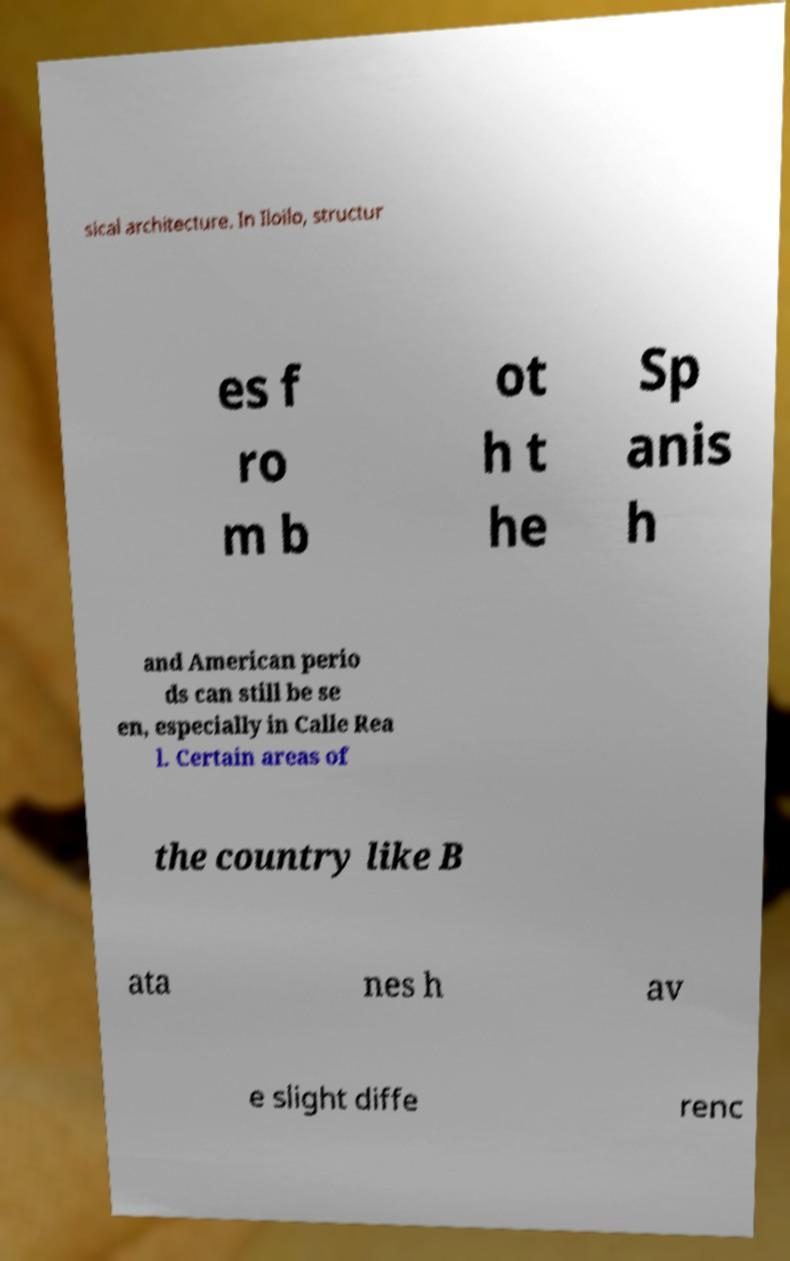Please identify and transcribe the text found in this image. sical architecture. In Iloilo, structur es f ro m b ot h t he Sp anis h and American perio ds can still be se en, especially in Calle Rea l. Certain areas of the country like B ata nes h av e slight diffe renc 